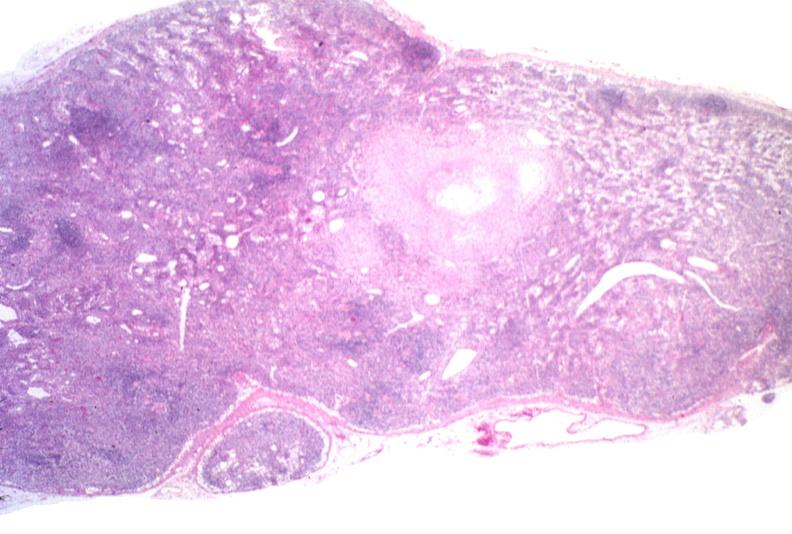what does this image show?
Answer the question using a single word or phrase. Lymph node 